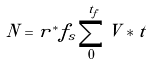<formula> <loc_0><loc_0><loc_500><loc_500>N = r ^ { * } f _ { s } \sum ^ { t _ { f } } _ { 0 } V * t</formula> 